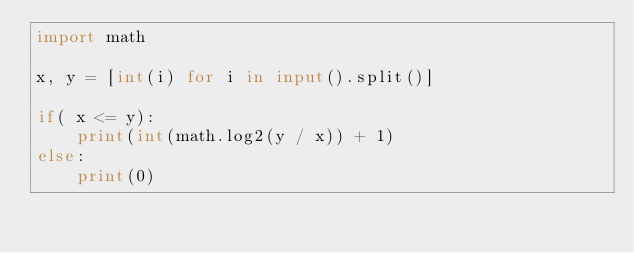Convert code to text. <code><loc_0><loc_0><loc_500><loc_500><_Python_>import math

x, y = [int(i) for i in input().split()]

if( x <= y):
    print(int(math.log2(y / x)) + 1)
else:
    print(0)</code> 